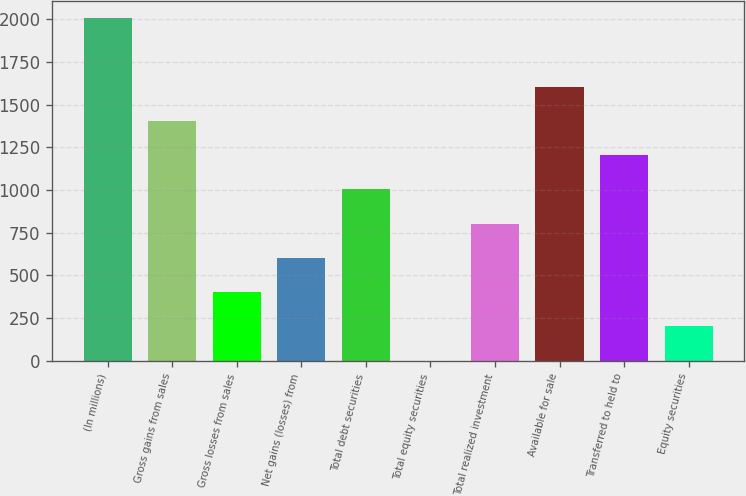Convert chart. <chart><loc_0><loc_0><loc_500><loc_500><bar_chart><fcel>(In millions)<fcel>Gross gains from sales<fcel>Gross losses from sales<fcel>Net gains (losses) from<fcel>Total debt securities<fcel>Total equity securities<fcel>Total realized investment<fcel>Available for sale<fcel>Transferred to held to<fcel>Equity securities<nl><fcel>2007<fcel>1405.2<fcel>402.2<fcel>602.8<fcel>1004<fcel>1<fcel>803.4<fcel>1605.8<fcel>1204.6<fcel>201.6<nl></chart> 